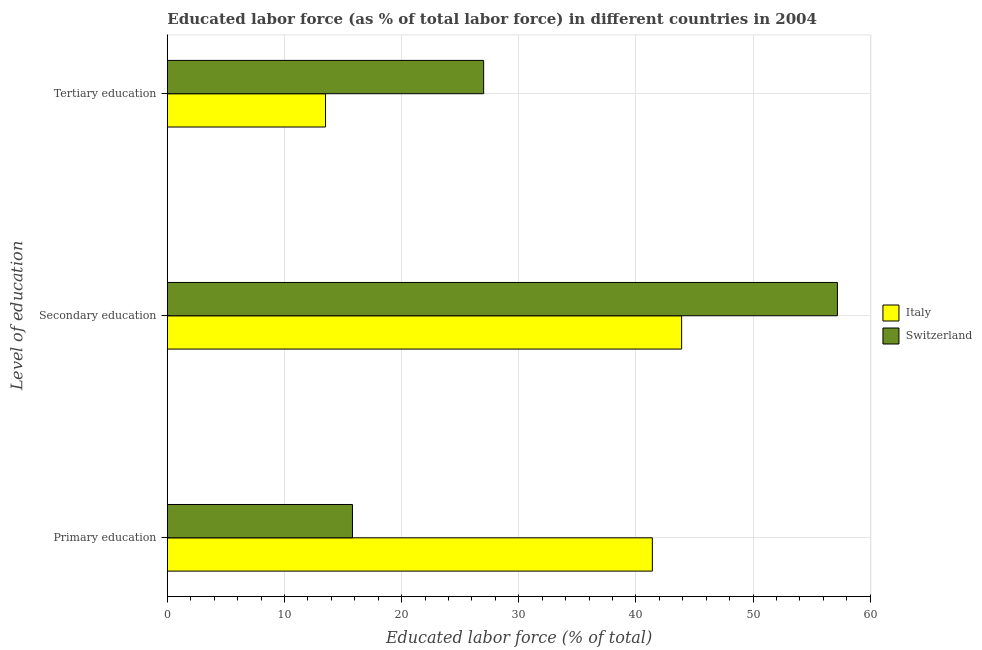How many different coloured bars are there?
Provide a short and direct response. 2. Are the number of bars on each tick of the Y-axis equal?
Your answer should be very brief. Yes. What is the label of the 1st group of bars from the top?
Provide a succinct answer. Tertiary education. Across all countries, what is the maximum percentage of labor force who received primary education?
Make the answer very short. 41.4. Across all countries, what is the minimum percentage of labor force who received tertiary education?
Give a very brief answer. 13.5. In which country was the percentage of labor force who received secondary education maximum?
Provide a succinct answer. Switzerland. What is the total percentage of labor force who received secondary education in the graph?
Your answer should be very brief. 101.1. What is the difference between the percentage of labor force who received primary education in Italy and that in Switzerland?
Your answer should be very brief. 25.6. What is the difference between the percentage of labor force who received tertiary education in Switzerland and the percentage of labor force who received primary education in Italy?
Your response must be concise. -14.4. What is the average percentage of labor force who received primary education per country?
Your answer should be compact. 28.6. What is the ratio of the percentage of labor force who received secondary education in Italy to that in Switzerland?
Ensure brevity in your answer.  0.77. Is the difference between the percentage of labor force who received tertiary education in Italy and Switzerland greater than the difference between the percentage of labor force who received primary education in Italy and Switzerland?
Offer a very short reply. No. What is the difference between the highest and the second highest percentage of labor force who received primary education?
Your response must be concise. 25.6. What is the difference between the highest and the lowest percentage of labor force who received secondary education?
Provide a short and direct response. 13.3. In how many countries, is the percentage of labor force who received tertiary education greater than the average percentage of labor force who received tertiary education taken over all countries?
Your answer should be compact. 1. What does the 2nd bar from the bottom in Tertiary education represents?
Give a very brief answer. Switzerland. How many bars are there?
Your answer should be very brief. 6. Are all the bars in the graph horizontal?
Offer a very short reply. Yes. How many countries are there in the graph?
Offer a very short reply. 2. What is the difference between two consecutive major ticks on the X-axis?
Make the answer very short. 10. Are the values on the major ticks of X-axis written in scientific E-notation?
Your answer should be compact. No. Does the graph contain any zero values?
Make the answer very short. No. Where does the legend appear in the graph?
Offer a very short reply. Center right. What is the title of the graph?
Your answer should be very brief. Educated labor force (as % of total labor force) in different countries in 2004. Does "Samoa" appear as one of the legend labels in the graph?
Your answer should be compact. No. What is the label or title of the X-axis?
Your response must be concise. Educated labor force (% of total). What is the label or title of the Y-axis?
Ensure brevity in your answer.  Level of education. What is the Educated labor force (% of total) in Italy in Primary education?
Give a very brief answer. 41.4. What is the Educated labor force (% of total) in Switzerland in Primary education?
Provide a short and direct response. 15.8. What is the Educated labor force (% of total) of Italy in Secondary education?
Offer a very short reply. 43.9. What is the Educated labor force (% of total) of Switzerland in Secondary education?
Give a very brief answer. 57.2. What is the Educated labor force (% of total) in Italy in Tertiary education?
Your answer should be compact. 13.5. What is the Educated labor force (% of total) of Switzerland in Tertiary education?
Your response must be concise. 27. Across all Level of education, what is the maximum Educated labor force (% of total) of Italy?
Keep it short and to the point. 43.9. Across all Level of education, what is the maximum Educated labor force (% of total) in Switzerland?
Your response must be concise. 57.2. Across all Level of education, what is the minimum Educated labor force (% of total) of Italy?
Provide a succinct answer. 13.5. Across all Level of education, what is the minimum Educated labor force (% of total) in Switzerland?
Your answer should be compact. 15.8. What is the total Educated labor force (% of total) in Italy in the graph?
Keep it short and to the point. 98.8. What is the total Educated labor force (% of total) of Switzerland in the graph?
Make the answer very short. 100. What is the difference between the Educated labor force (% of total) in Italy in Primary education and that in Secondary education?
Ensure brevity in your answer.  -2.5. What is the difference between the Educated labor force (% of total) in Switzerland in Primary education and that in Secondary education?
Your answer should be compact. -41.4. What is the difference between the Educated labor force (% of total) in Italy in Primary education and that in Tertiary education?
Provide a short and direct response. 27.9. What is the difference between the Educated labor force (% of total) of Italy in Secondary education and that in Tertiary education?
Offer a very short reply. 30.4. What is the difference between the Educated labor force (% of total) of Switzerland in Secondary education and that in Tertiary education?
Make the answer very short. 30.2. What is the difference between the Educated labor force (% of total) of Italy in Primary education and the Educated labor force (% of total) of Switzerland in Secondary education?
Your response must be concise. -15.8. What is the difference between the Educated labor force (% of total) of Italy in Primary education and the Educated labor force (% of total) of Switzerland in Tertiary education?
Offer a terse response. 14.4. What is the average Educated labor force (% of total) of Italy per Level of education?
Your response must be concise. 32.93. What is the average Educated labor force (% of total) in Switzerland per Level of education?
Keep it short and to the point. 33.33. What is the difference between the Educated labor force (% of total) of Italy and Educated labor force (% of total) of Switzerland in Primary education?
Your response must be concise. 25.6. What is the difference between the Educated labor force (% of total) of Italy and Educated labor force (% of total) of Switzerland in Secondary education?
Provide a short and direct response. -13.3. What is the ratio of the Educated labor force (% of total) in Italy in Primary education to that in Secondary education?
Your response must be concise. 0.94. What is the ratio of the Educated labor force (% of total) of Switzerland in Primary education to that in Secondary education?
Keep it short and to the point. 0.28. What is the ratio of the Educated labor force (% of total) of Italy in Primary education to that in Tertiary education?
Offer a very short reply. 3.07. What is the ratio of the Educated labor force (% of total) of Switzerland in Primary education to that in Tertiary education?
Give a very brief answer. 0.59. What is the ratio of the Educated labor force (% of total) in Italy in Secondary education to that in Tertiary education?
Your answer should be very brief. 3.25. What is the ratio of the Educated labor force (% of total) of Switzerland in Secondary education to that in Tertiary education?
Provide a succinct answer. 2.12. What is the difference between the highest and the second highest Educated labor force (% of total) of Switzerland?
Your answer should be compact. 30.2. What is the difference between the highest and the lowest Educated labor force (% of total) of Italy?
Your answer should be very brief. 30.4. What is the difference between the highest and the lowest Educated labor force (% of total) of Switzerland?
Make the answer very short. 41.4. 